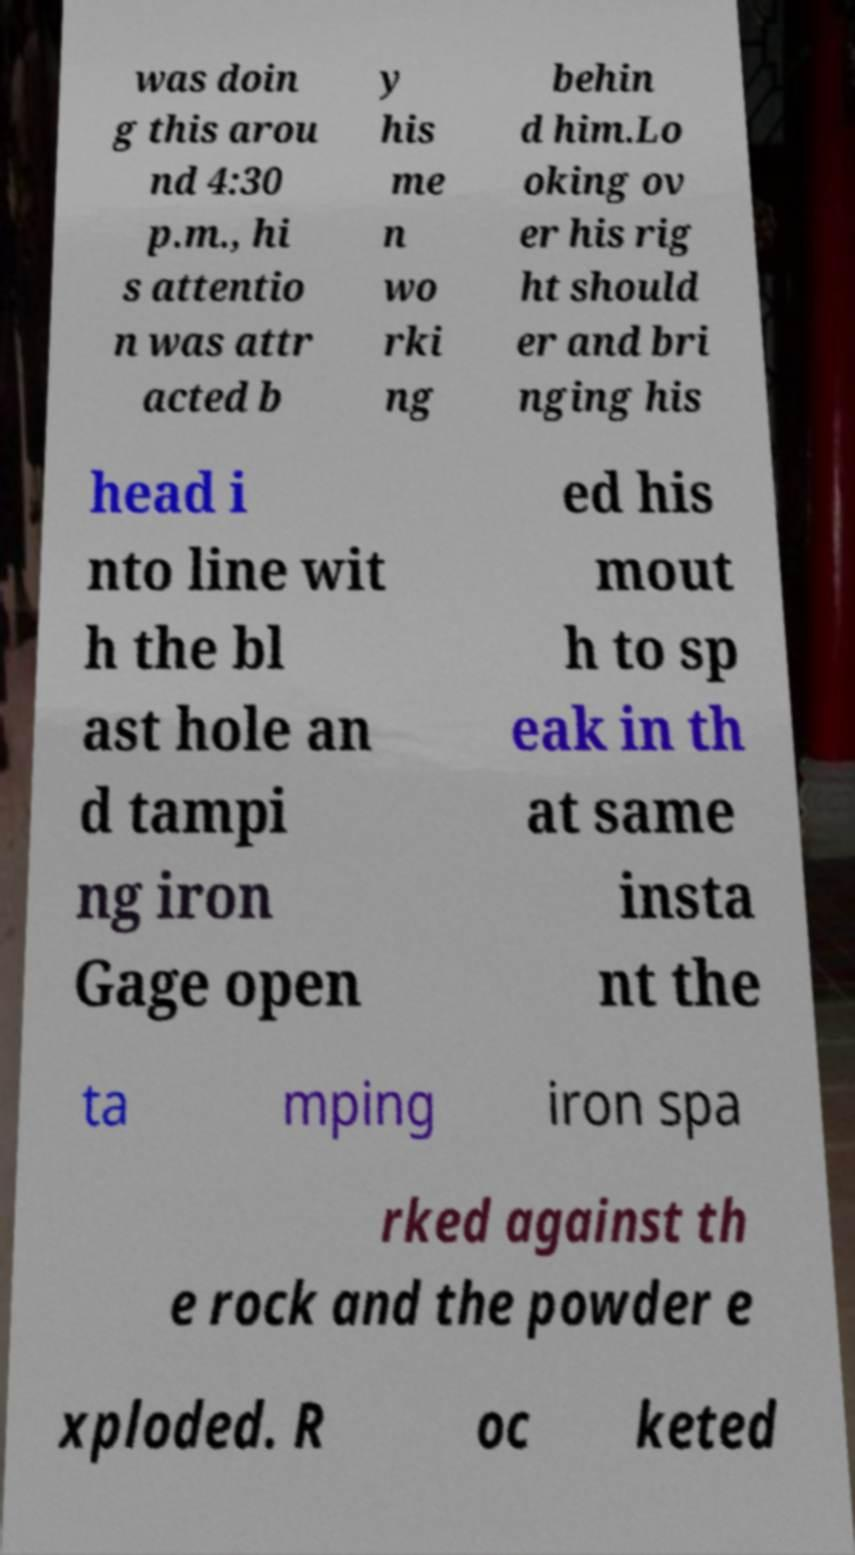Could you extract and type out the text from this image? was doin g this arou nd 4:30 p.m., hi s attentio n was attr acted b y his me n wo rki ng behin d him.Lo oking ov er his rig ht should er and bri nging his head i nto line wit h the bl ast hole an d tampi ng iron Gage open ed his mout h to sp eak in th at same insta nt the ta mping iron spa rked against th e rock and the powder e xploded. R oc keted 